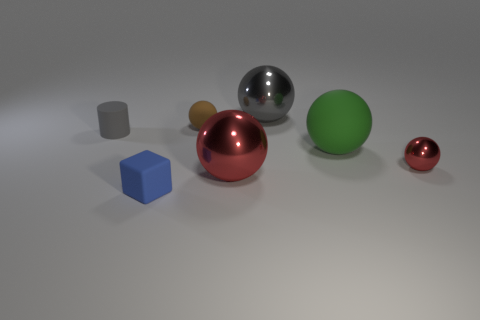There is a big sphere that is behind the gray rubber cylinder on the left side of the cube; what color is it?
Give a very brief answer. Gray. What number of small rubber cubes are there?
Ensure brevity in your answer.  1. Does the tiny cube have the same color as the big matte object?
Make the answer very short. No. Are there fewer tiny matte cubes in front of the tiny blue object than small cylinders behind the tiny metallic thing?
Keep it short and to the point. Yes. The big matte sphere has what color?
Your response must be concise. Green. How many small balls have the same color as the cube?
Your answer should be very brief. 0. There is a big gray shiny sphere; are there any gray objects on the left side of it?
Keep it short and to the point. Yes. Are there the same number of big metal spheres behind the tiny red thing and brown balls that are to the left of the tiny cylinder?
Offer a terse response. No. There is a ball left of the large red thing; is it the same size as the metallic object that is to the right of the big rubber sphere?
Provide a short and direct response. Yes. There is a small rubber thing left of the small matte thing in front of the rubber thing on the left side of the blue block; what is its shape?
Ensure brevity in your answer.  Cylinder. 